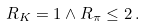Convert formula to latex. <formula><loc_0><loc_0><loc_500><loc_500>R _ { K } = 1 \wedge R _ { \pi } \leq 2 \, .</formula> 